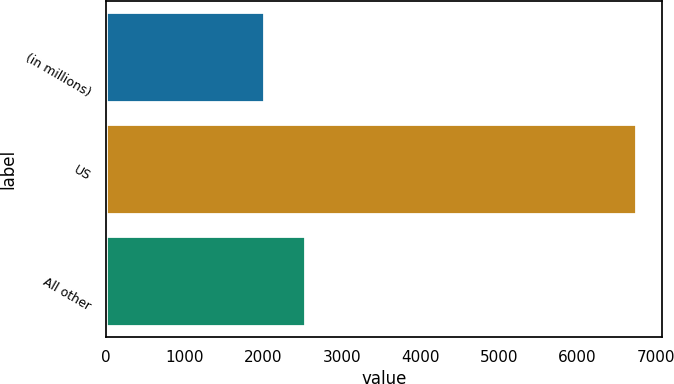Convert chart to OTSL. <chart><loc_0><loc_0><loc_500><loc_500><bar_chart><fcel>(in millions)<fcel>US<fcel>All other<nl><fcel>2012<fcel>6743<fcel>2533<nl></chart> 